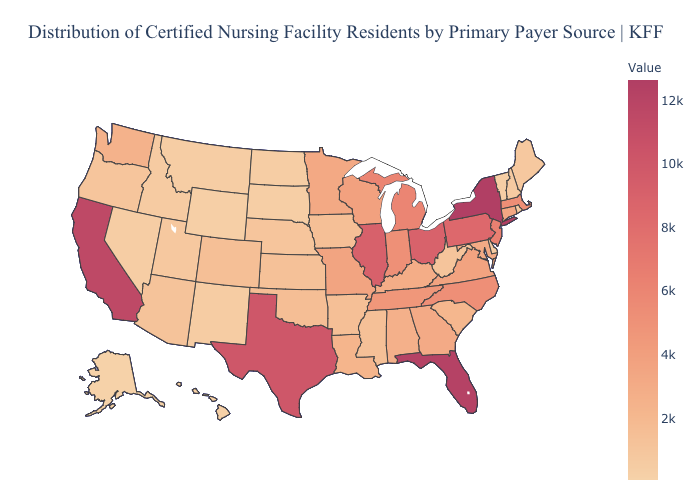Which states have the lowest value in the USA?
Write a very short answer. Alaska. Which states have the lowest value in the South?
Quick response, please. Delaware. Does Alaska have the lowest value in the USA?
Quick response, please. Yes. Among the states that border North Dakota , does Montana have the lowest value?
Give a very brief answer. No. Does Mississippi have a higher value than Alaska?
Keep it brief. Yes. 